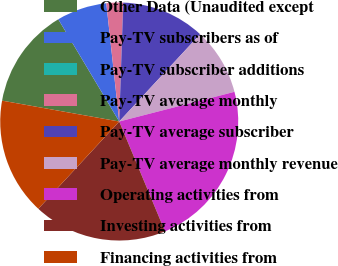<chart> <loc_0><loc_0><loc_500><loc_500><pie_chart><fcel>Other Data (Unaudited except<fcel>Pay-TV subscribers as of<fcel>Pay-TV subscriber additions<fcel>Pay-TV average monthly<fcel>Pay-TV average subscriber<fcel>Pay-TV average monthly revenue<fcel>Operating activities from<fcel>Investing activities from<fcel>Financing activities from<nl><fcel>13.64%<fcel>6.82%<fcel>0.0%<fcel>2.27%<fcel>11.36%<fcel>9.09%<fcel>22.73%<fcel>18.18%<fcel>15.91%<nl></chart> 